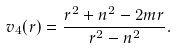Convert formula to latex. <formula><loc_0><loc_0><loc_500><loc_500>v _ { 4 } ( r ) = \frac { r ^ { 2 } + n ^ { 2 } - 2 m r } { r ^ { 2 } - n ^ { 2 } } .</formula> 